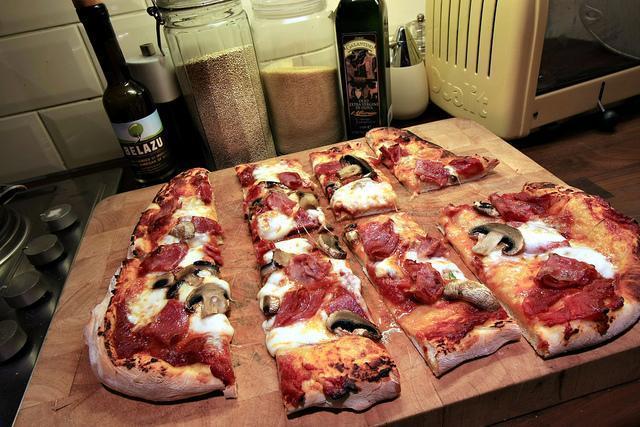How many bottles are there?
Give a very brief answer. 4. How many pizzas can you see?
Give a very brief answer. 7. 